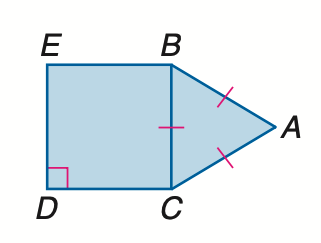Answer the mathemtical geometry problem and directly provide the correct option letter.
Question: Find the ratio of the area of \triangle A B C to the area of square B C D E.
Choices: A: 1 : 3 B: \frac { \sqrt 3 } { 4 } : 1 C: \frac { \sqrt 3 } { 2 } : 1 D: \sqrt { 3 } :1 B 